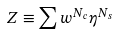Convert formula to latex. <formula><loc_0><loc_0><loc_500><loc_500>Z \equiv \sum w ^ { N _ { c } } \eta ^ { N _ { s } }</formula> 